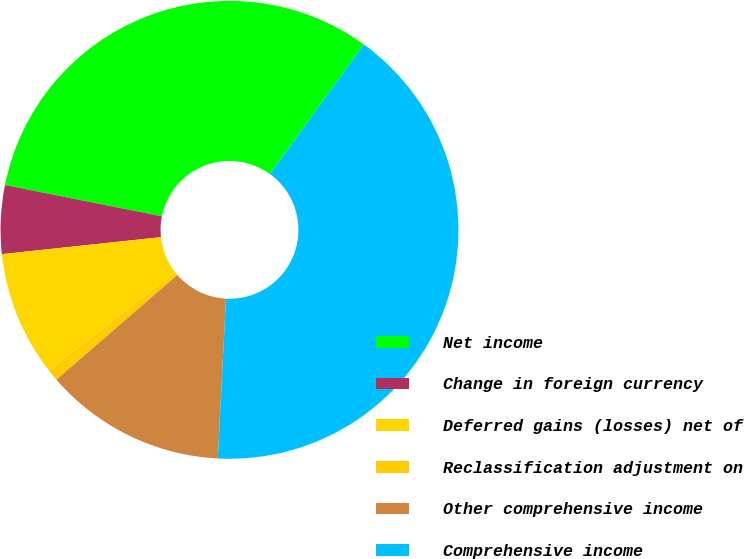Convert chart to OTSL. <chart><loc_0><loc_0><loc_500><loc_500><pie_chart><fcel>Net income<fcel>Change in foreign currency<fcel>Deferred gains (losses) net of<fcel>Reclassification adjustment on<fcel>Other comprehensive income<fcel>Comprehensive income<nl><fcel>31.84%<fcel>4.83%<fcel>8.83%<fcel>0.83%<fcel>12.83%<fcel>40.84%<nl></chart> 